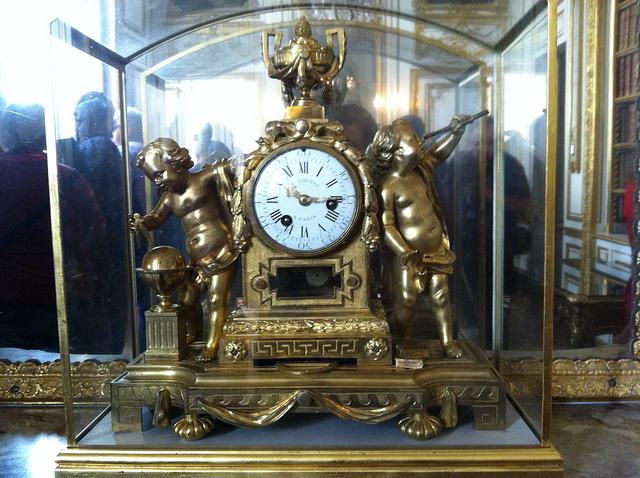What is located behind the clock?

Choices:
A) large room
B) mirror
C) open museum
D) nothing mirror 